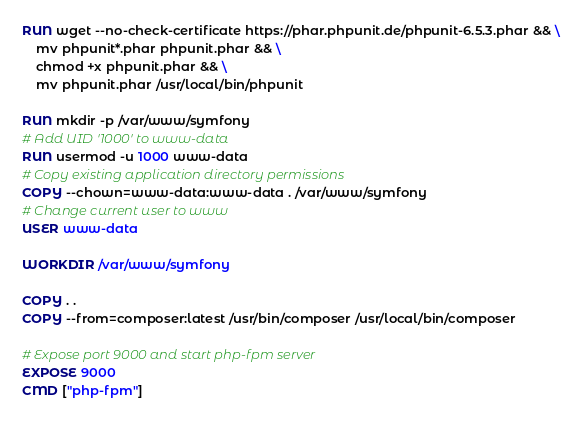Convert code to text. <code><loc_0><loc_0><loc_500><loc_500><_Dockerfile_>RUN wget --no-check-certificate https://phar.phpunit.de/phpunit-6.5.3.phar && \
    mv phpunit*.phar phpunit.phar && \
    chmod +x phpunit.phar && \
    mv phpunit.phar /usr/local/bin/phpunit

RUN mkdir -p /var/www/symfony
# Add UID '1000' to www-data
RUN usermod -u 1000 www-data
# Copy existing application directory permissions
COPY --chown=www-data:www-data . /var/www/symfony
# Change current user to www
USER www-data

WORKDIR /var/www/symfony

COPY . .
COPY --from=composer:latest /usr/bin/composer /usr/local/bin/composer

# Expose port 9000 and start php-fpm server
EXPOSE 9000
CMD ["php-fpm"]
</code> 